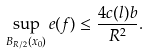Convert formula to latex. <formula><loc_0><loc_0><loc_500><loc_500>\sup _ { B _ { R / 2 } ( x _ { 0 } ) } e ( f ) \leq \frac { 4 c ( l ) b } { R ^ { 2 } } .</formula> 